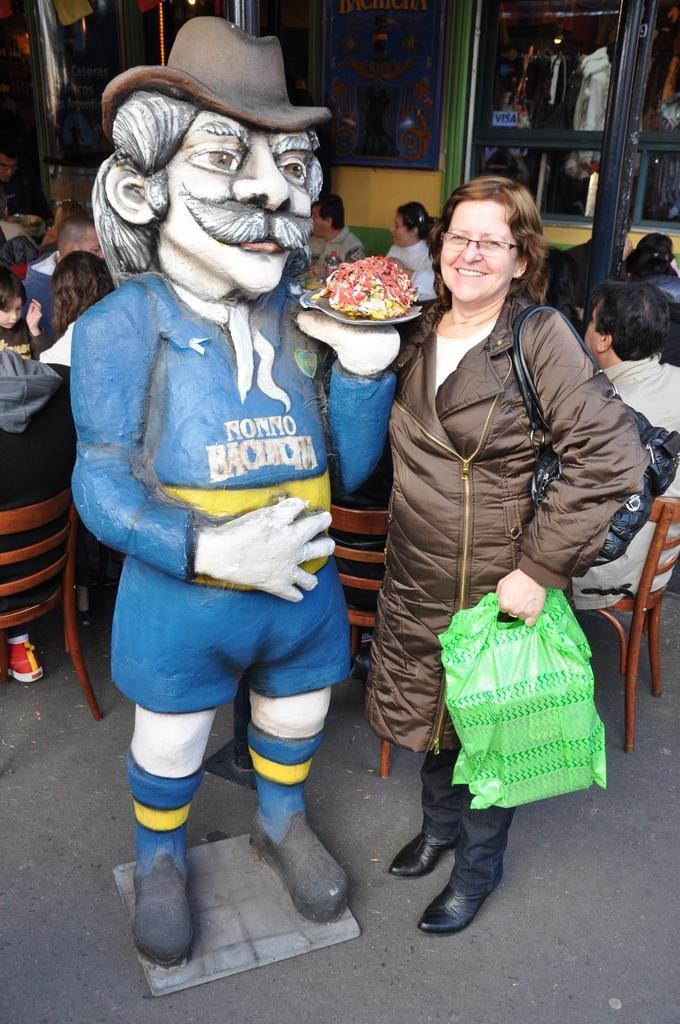Could you give a brief overview of what you see in this image? There is a lady holding a polythene and standing beside a statue in the foreground area of the image, there are people sitting around the table and windows in the background. 